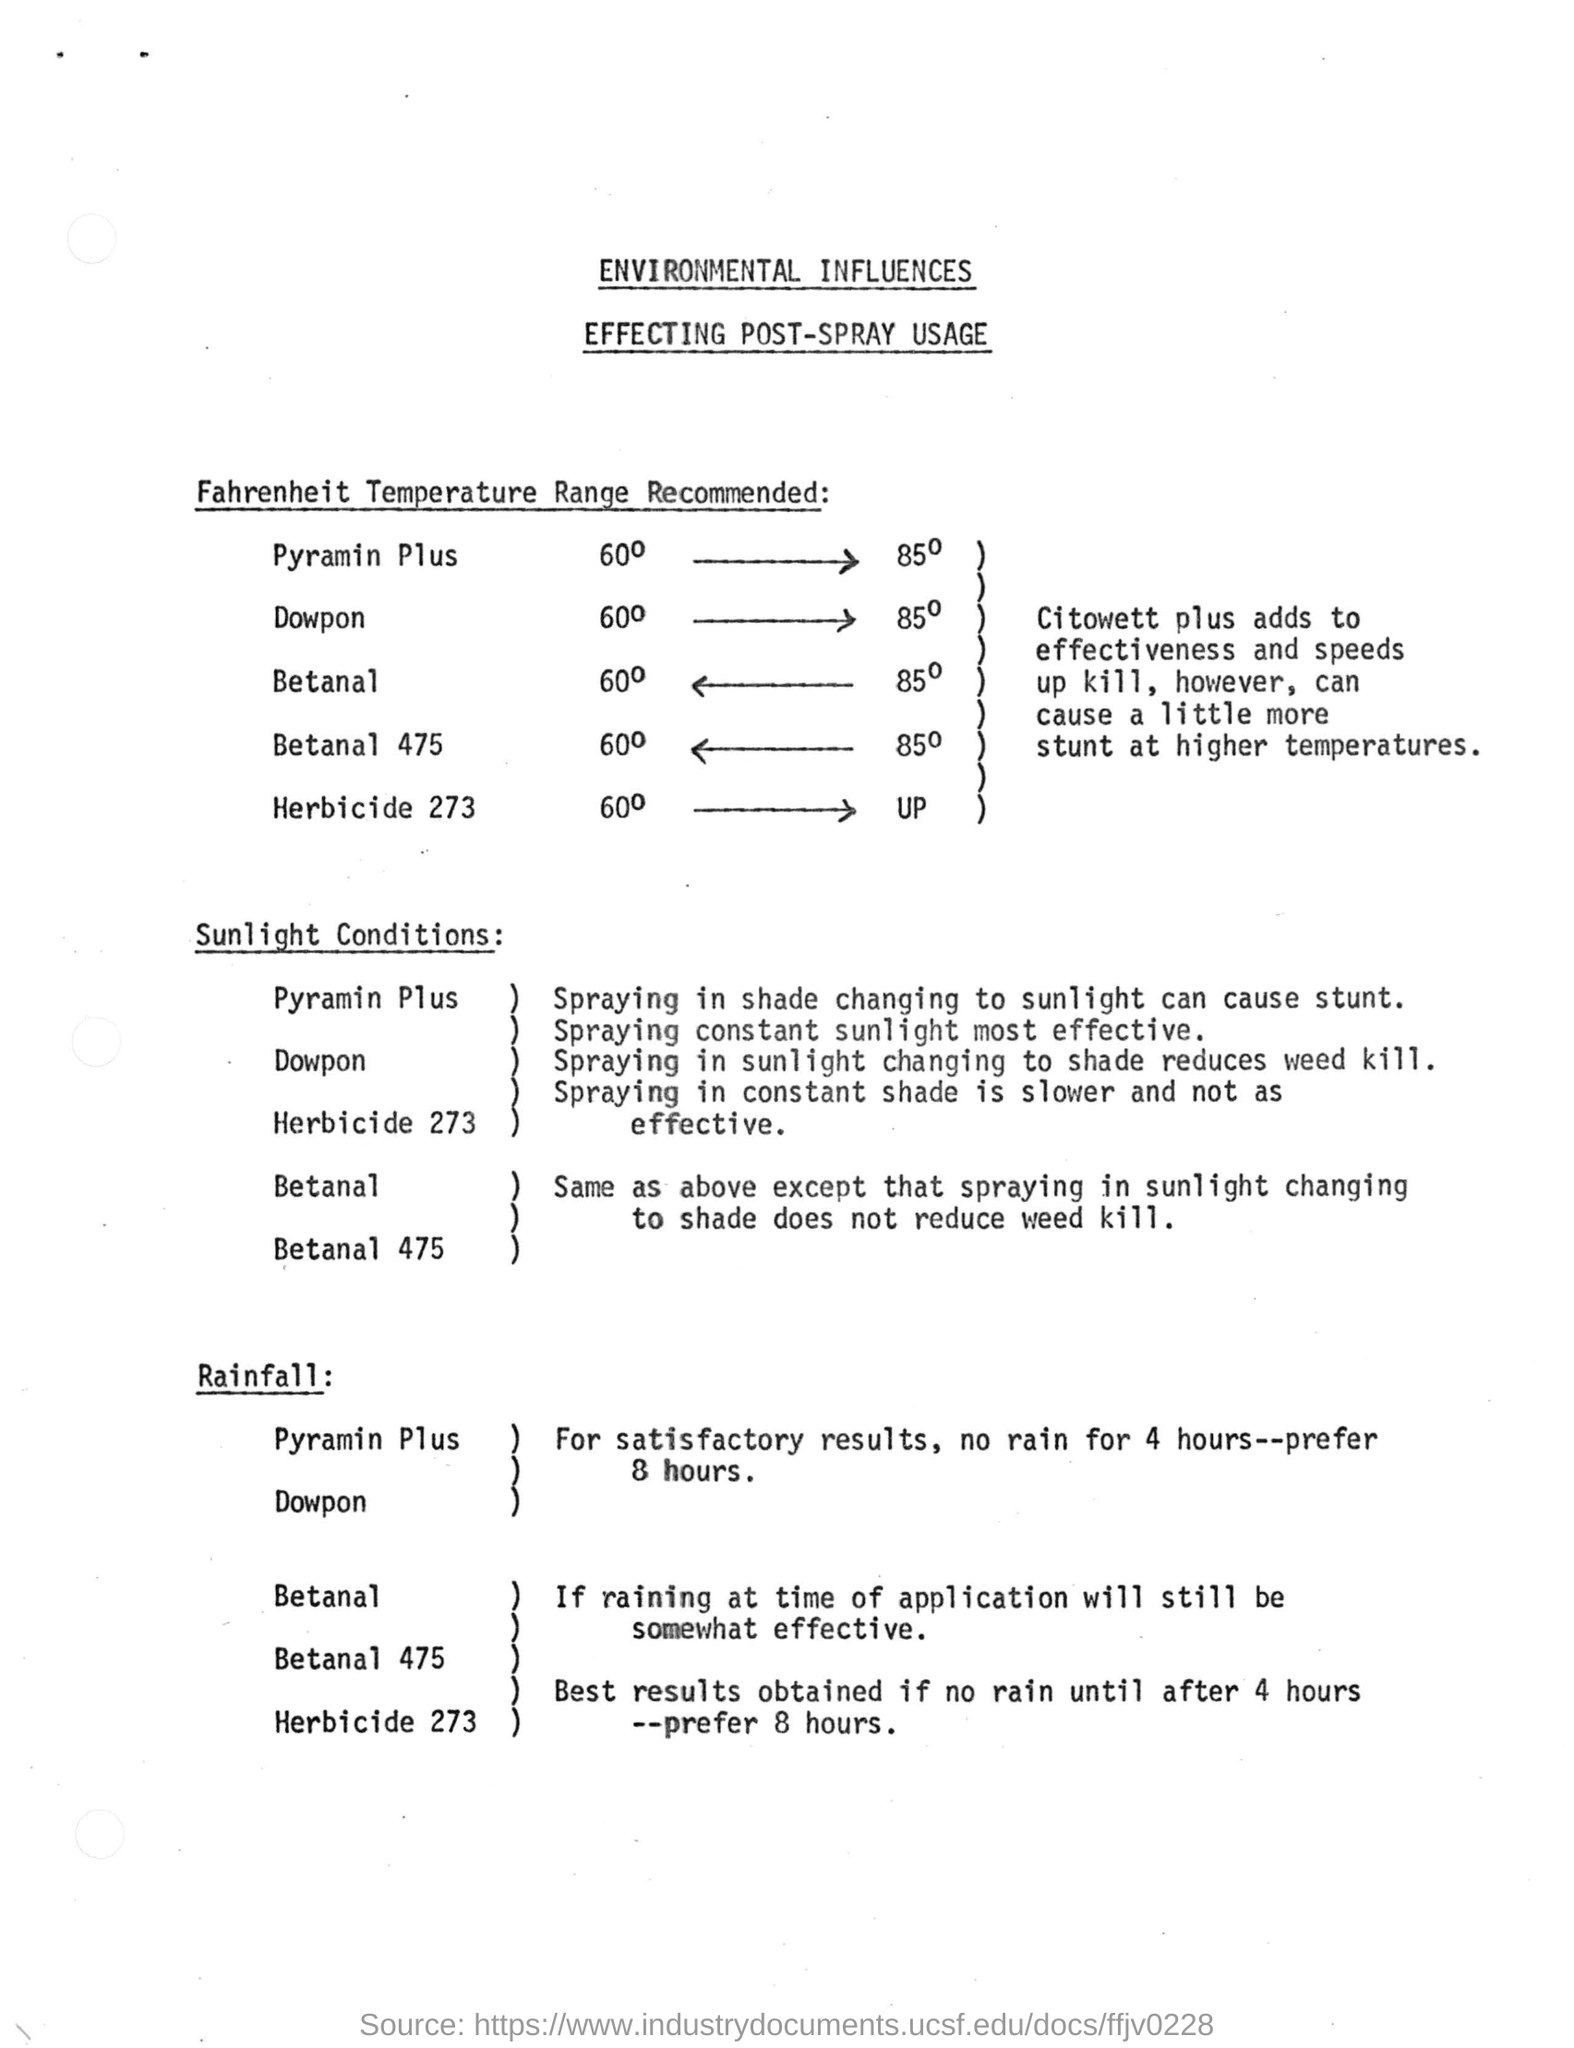Name of the document
Keep it short and to the point. ENVIRONMENTAL INFLUENCES EFFECTING POST-SPRAY USAGE. Citowett plus adds to effectiveness and speeds up kill, however, can cause a little more stunt at what temperatures
Provide a succinct answer. Higher. What can cause stunt
Your response must be concise. Spraying in shade changing to sunlight. What is slower and not as effective
Provide a succinct answer. Spraying in constant shade. 